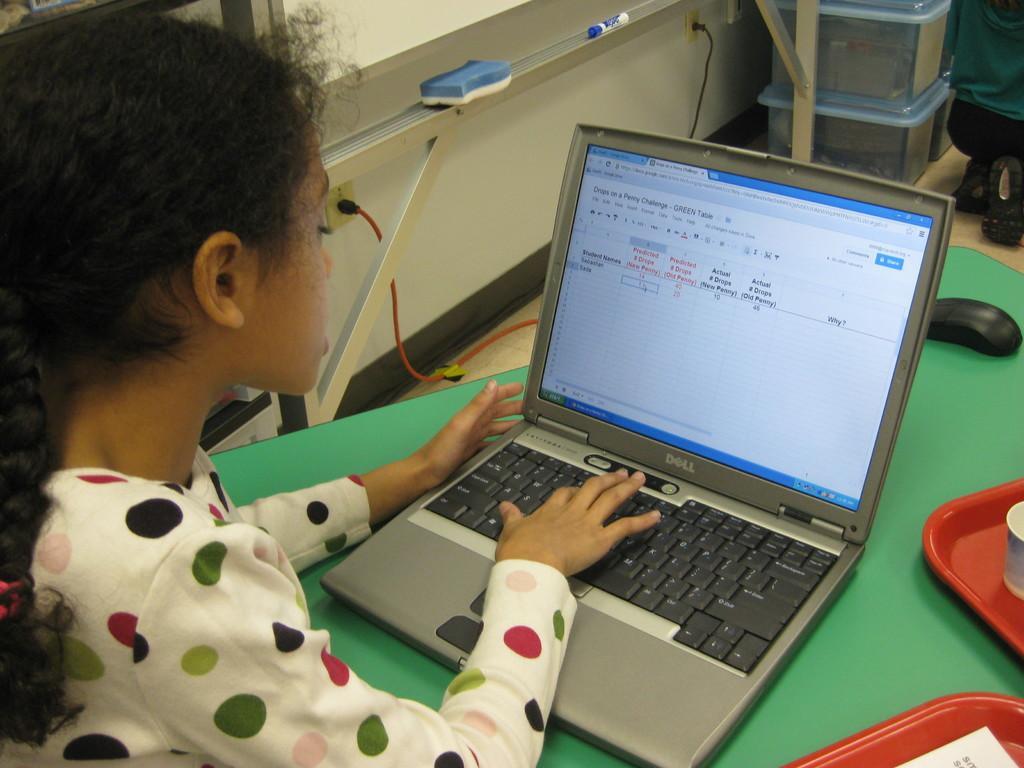Could you give a brief overview of what you see in this image? In this image there is a table. There are plates, a laptop and a mouse on the table. To the left there is a girl working on the laptop. At the top there is a wall. There is a duster on the board. Near to it there is a marker. In the top right there are boxes on the floor. 